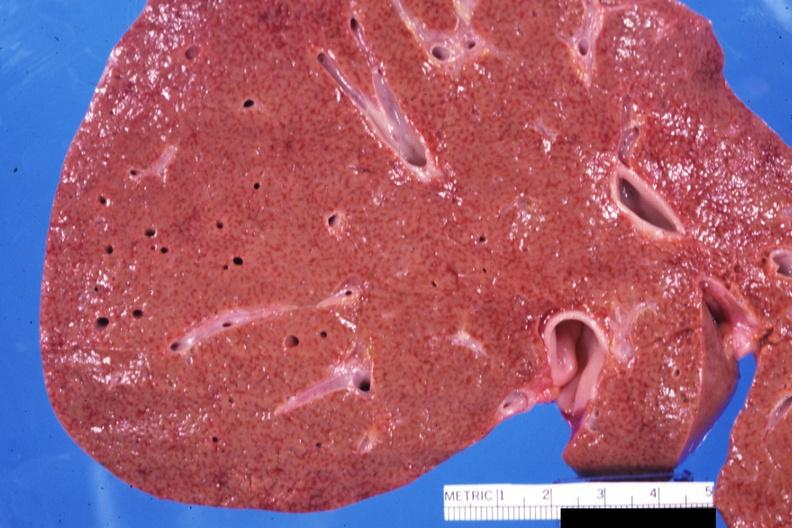what is present?
Answer the question using a single word or phrase. Liver 